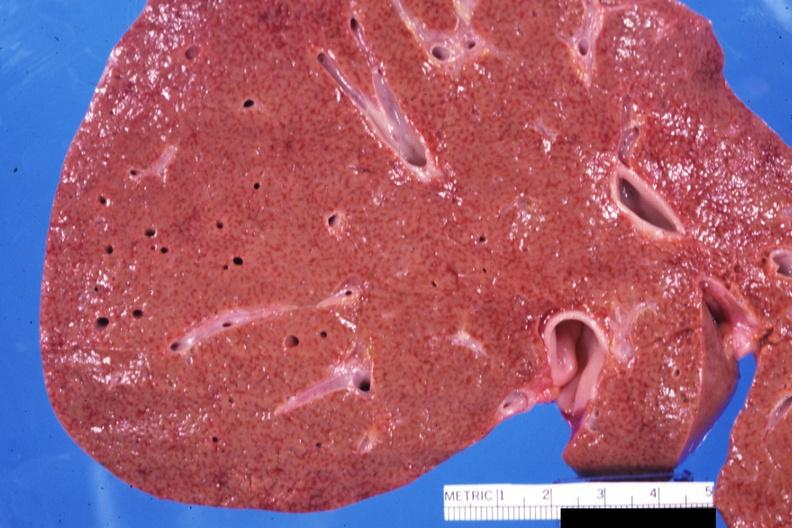what is present?
Answer the question using a single word or phrase. Liver 